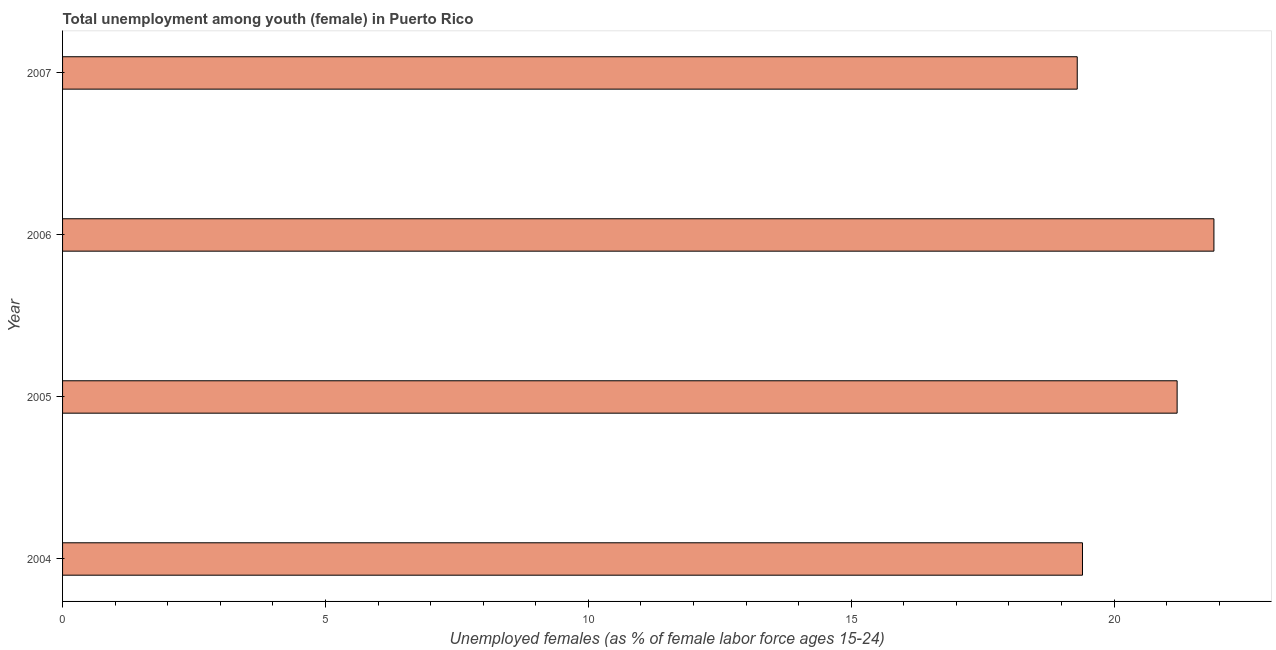Does the graph contain grids?
Offer a terse response. No. What is the title of the graph?
Provide a succinct answer. Total unemployment among youth (female) in Puerto Rico. What is the label or title of the X-axis?
Ensure brevity in your answer.  Unemployed females (as % of female labor force ages 15-24). What is the label or title of the Y-axis?
Ensure brevity in your answer.  Year. What is the unemployed female youth population in 2006?
Make the answer very short. 21.9. Across all years, what is the maximum unemployed female youth population?
Keep it short and to the point. 21.9. Across all years, what is the minimum unemployed female youth population?
Offer a terse response. 19.3. In which year was the unemployed female youth population minimum?
Make the answer very short. 2007. What is the sum of the unemployed female youth population?
Your response must be concise. 81.8. What is the average unemployed female youth population per year?
Offer a very short reply. 20.45. What is the median unemployed female youth population?
Provide a succinct answer. 20.3. In how many years, is the unemployed female youth population greater than 1 %?
Your answer should be very brief. 4. What is the ratio of the unemployed female youth population in 2004 to that in 2007?
Give a very brief answer. 1. Is the difference between the unemployed female youth population in 2006 and 2007 greater than the difference between any two years?
Give a very brief answer. Yes. In how many years, is the unemployed female youth population greater than the average unemployed female youth population taken over all years?
Keep it short and to the point. 2. How many bars are there?
Offer a very short reply. 4. Are all the bars in the graph horizontal?
Keep it short and to the point. Yes. What is the Unemployed females (as % of female labor force ages 15-24) in 2004?
Your answer should be compact. 19.4. What is the Unemployed females (as % of female labor force ages 15-24) of 2005?
Your answer should be compact. 21.2. What is the Unemployed females (as % of female labor force ages 15-24) of 2006?
Provide a short and direct response. 21.9. What is the Unemployed females (as % of female labor force ages 15-24) in 2007?
Make the answer very short. 19.3. What is the difference between the Unemployed females (as % of female labor force ages 15-24) in 2004 and 2005?
Your answer should be very brief. -1.8. What is the difference between the Unemployed females (as % of female labor force ages 15-24) in 2005 and 2007?
Give a very brief answer. 1.9. What is the difference between the Unemployed females (as % of female labor force ages 15-24) in 2006 and 2007?
Your answer should be compact. 2.6. What is the ratio of the Unemployed females (as % of female labor force ages 15-24) in 2004 to that in 2005?
Give a very brief answer. 0.92. What is the ratio of the Unemployed females (as % of female labor force ages 15-24) in 2004 to that in 2006?
Offer a terse response. 0.89. What is the ratio of the Unemployed females (as % of female labor force ages 15-24) in 2005 to that in 2006?
Your answer should be compact. 0.97. What is the ratio of the Unemployed females (as % of female labor force ages 15-24) in 2005 to that in 2007?
Your answer should be compact. 1.1. What is the ratio of the Unemployed females (as % of female labor force ages 15-24) in 2006 to that in 2007?
Keep it short and to the point. 1.14. 